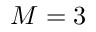<formula> <loc_0><loc_0><loc_500><loc_500>M = 3</formula> 